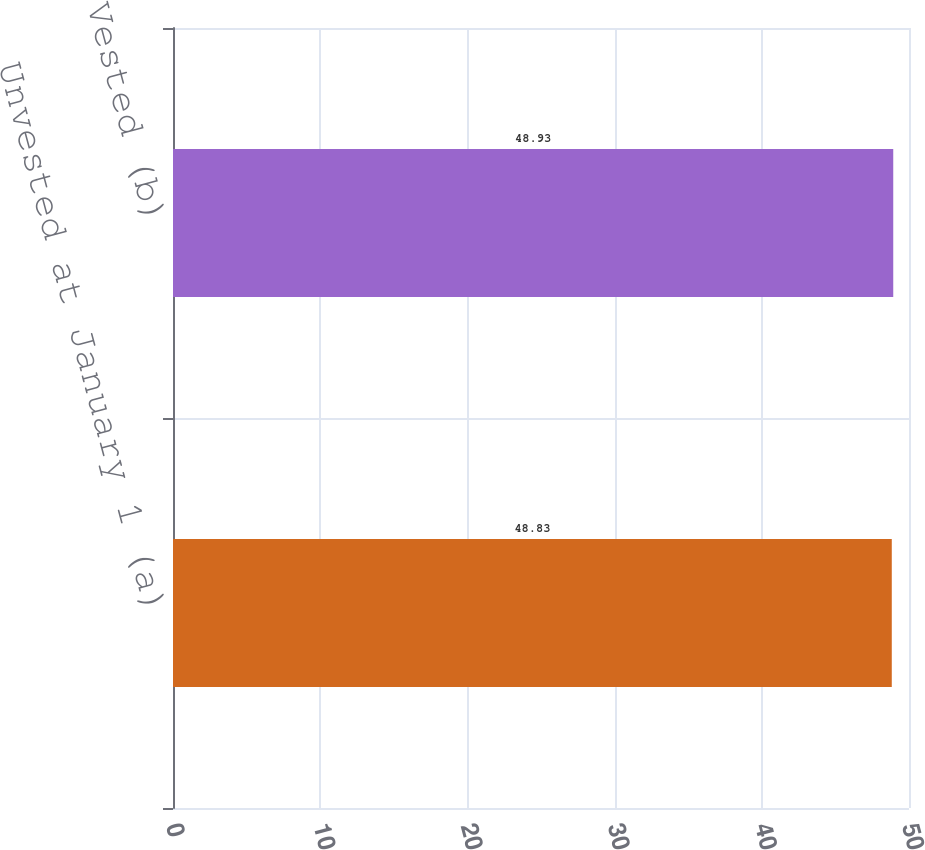<chart> <loc_0><loc_0><loc_500><loc_500><bar_chart><fcel>Unvested at January 1 (a)<fcel>Vested (b)<nl><fcel>48.83<fcel>48.93<nl></chart> 